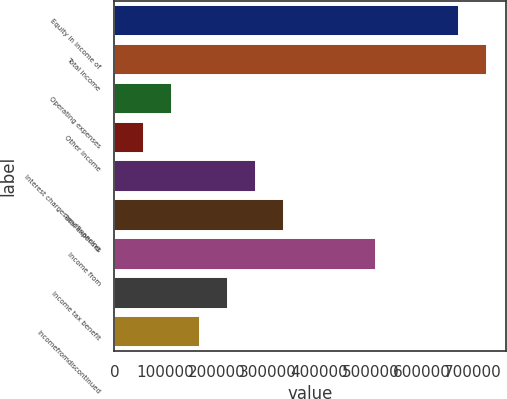Convert chart. <chart><loc_0><loc_0><loc_500><loc_500><bar_chart><fcel>Equity in income of<fcel>Total income<fcel>Operating expenses<fcel>Other income<fcel>Interest charges andfinancing<fcel>Total expenses<fcel>Income from<fcel>Income tax benefit<fcel>Incomefromdiscontinued<nl><fcel>673929<fcel>728258<fcel>112898<fcel>58569.3<fcel>275882<fcel>330211<fcel>510944<fcel>221554<fcel>167226<nl></chart> 